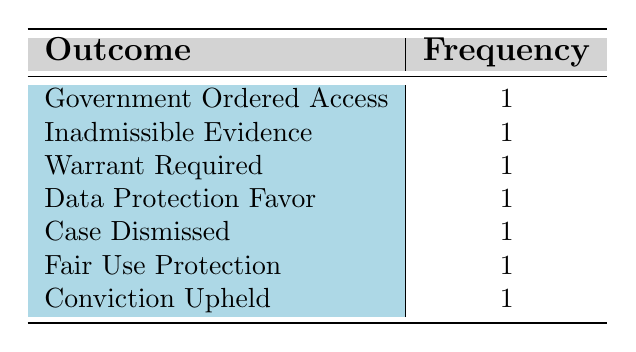What is the total number of unique legal outcomes listed in the table? The table lists seven distinct outcomes: Government Ordered Access, Inadmissible Evidence, Warrant Required, Data Protection Favor, Case Dismissed, Fair Use Protection, and Conviction Upheld. Counting these unique entries gives a total of 7.
Answer: 7 Which legal outcome occurred in the year 2016? Referring to the table, the case from 2016 is "United States v. Apple Inc." with the outcome "Government Ordered Access."
Answer: Government Ordered Access Is there any case where the outcome was "Data Protection Favor"? Looking at the table, "Data Protection Favor" is indeed listed as the outcome for the case "Facebook, Inc. v. Warrington" in 2020. Therefore, the statement is true.
Answer: Yes How many cases resulted in "Inadmissible Evidence" or "Case Dismissed"? The table shows that there is one case for each of those outcomes: "R. v. Oakes" resulted in "Inadmissible Evidence" and "R. v. Reddick" resulted in "Case Dismissed." Therefore, the total is 1 + 1 = 2.
Answer: 2 Which outcome was repeated the most in the table? In the table, each listed legal outcome appears exactly once; therefore, no outcome is repeated more than others. The frequency of each outcome is the same.
Answer: None; each outcome appears once What is the average number of cases per unique legal outcome? There are 7 outcomes and 7 cases listed in the table. To find the average, we divide the total number of cases (7) by the number of unique outcomes (7), which results in an average of 1 case per outcome.
Answer: 1 Was there a case in the year 2019 with an outcome different from "Government Ordered Access"? According to the table, the case "R. v. Reddick," which occurred in 2019, had an outcome of "Case Dismissed." Since this is different from "Government Ordered Access," the answer is yes.
Answer: Yes How many cases achieved a favorable outcome for data protection? The only case that achieved a favorable outcome for data protection is "Facebook, Inc. v. Warrington," thus there is only one case in this category.
Answer: 1 